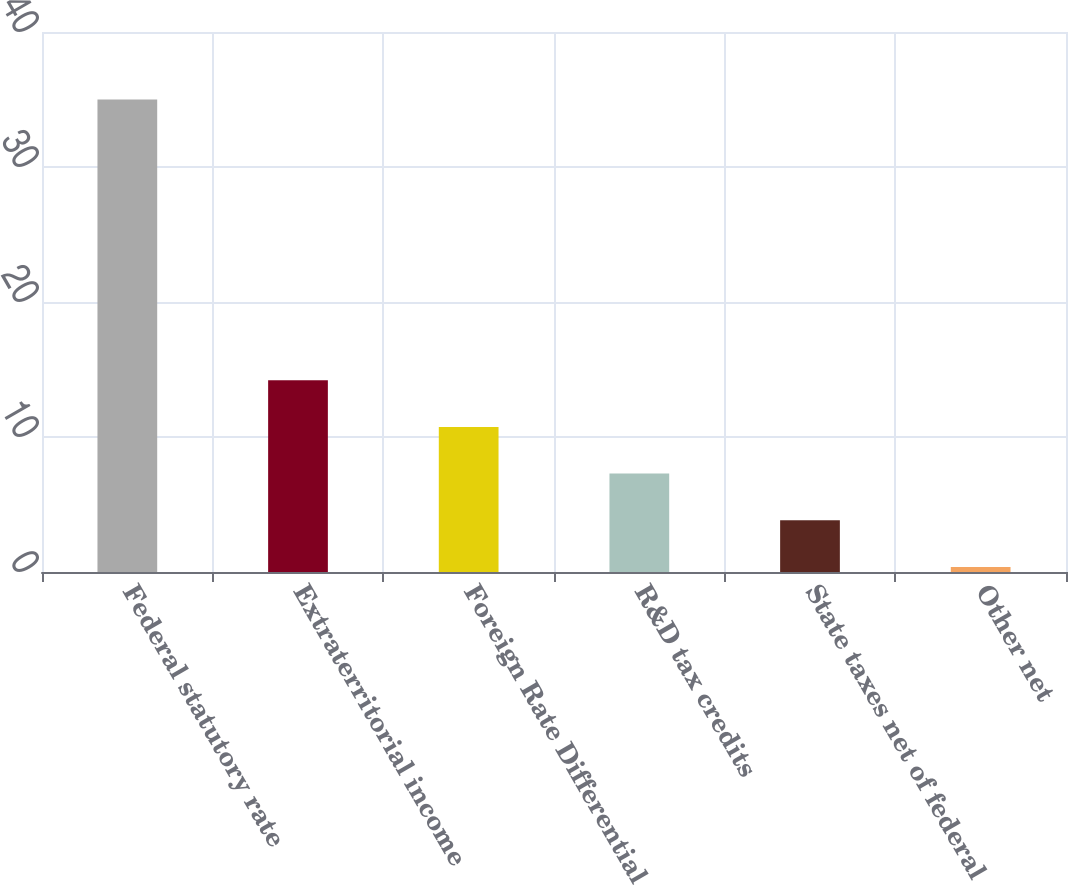Convert chart. <chart><loc_0><loc_0><loc_500><loc_500><bar_chart><fcel>Federal statutory rate<fcel>Extraterritorial income<fcel>Foreign Rate Differential<fcel>R&D tax credits<fcel>State taxes net of federal<fcel>Other net<nl><fcel>35<fcel>14.21<fcel>10.75<fcel>7.29<fcel>3.83<fcel>0.37<nl></chart> 